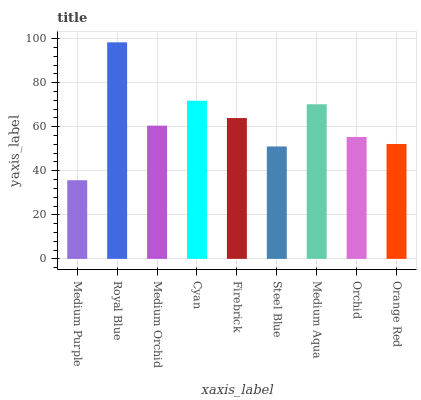Is Medium Purple the minimum?
Answer yes or no. Yes. Is Royal Blue the maximum?
Answer yes or no. Yes. Is Medium Orchid the minimum?
Answer yes or no. No. Is Medium Orchid the maximum?
Answer yes or no. No. Is Royal Blue greater than Medium Orchid?
Answer yes or no. Yes. Is Medium Orchid less than Royal Blue?
Answer yes or no. Yes. Is Medium Orchid greater than Royal Blue?
Answer yes or no. No. Is Royal Blue less than Medium Orchid?
Answer yes or no. No. Is Medium Orchid the high median?
Answer yes or no. Yes. Is Medium Orchid the low median?
Answer yes or no. Yes. Is Cyan the high median?
Answer yes or no. No. Is Firebrick the low median?
Answer yes or no. No. 